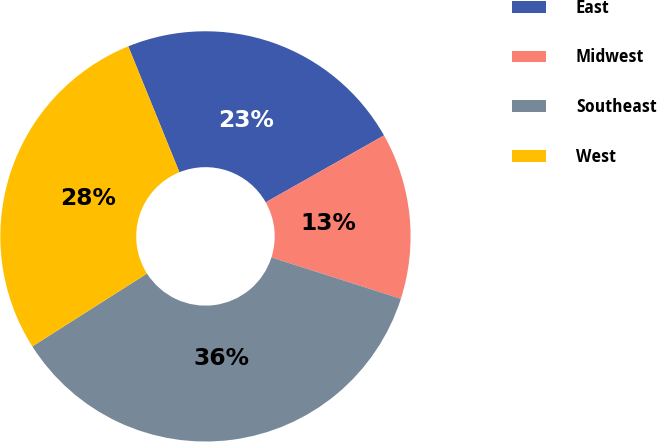<chart> <loc_0><loc_0><loc_500><loc_500><pie_chart><fcel>East<fcel>Midwest<fcel>Southeast<fcel>West<nl><fcel>22.95%<fcel>13.11%<fcel>36.07%<fcel>27.87%<nl></chart> 